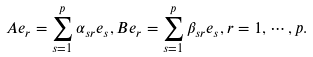<formula> <loc_0><loc_0><loc_500><loc_500>A e _ { r } = \sum _ { s = 1 } ^ { p } \alpha _ { s r } e _ { s } , B e _ { r } = \sum _ { s = 1 } ^ { p } \beta _ { s r } e _ { s } , r = 1 , \cdots , p .</formula> 